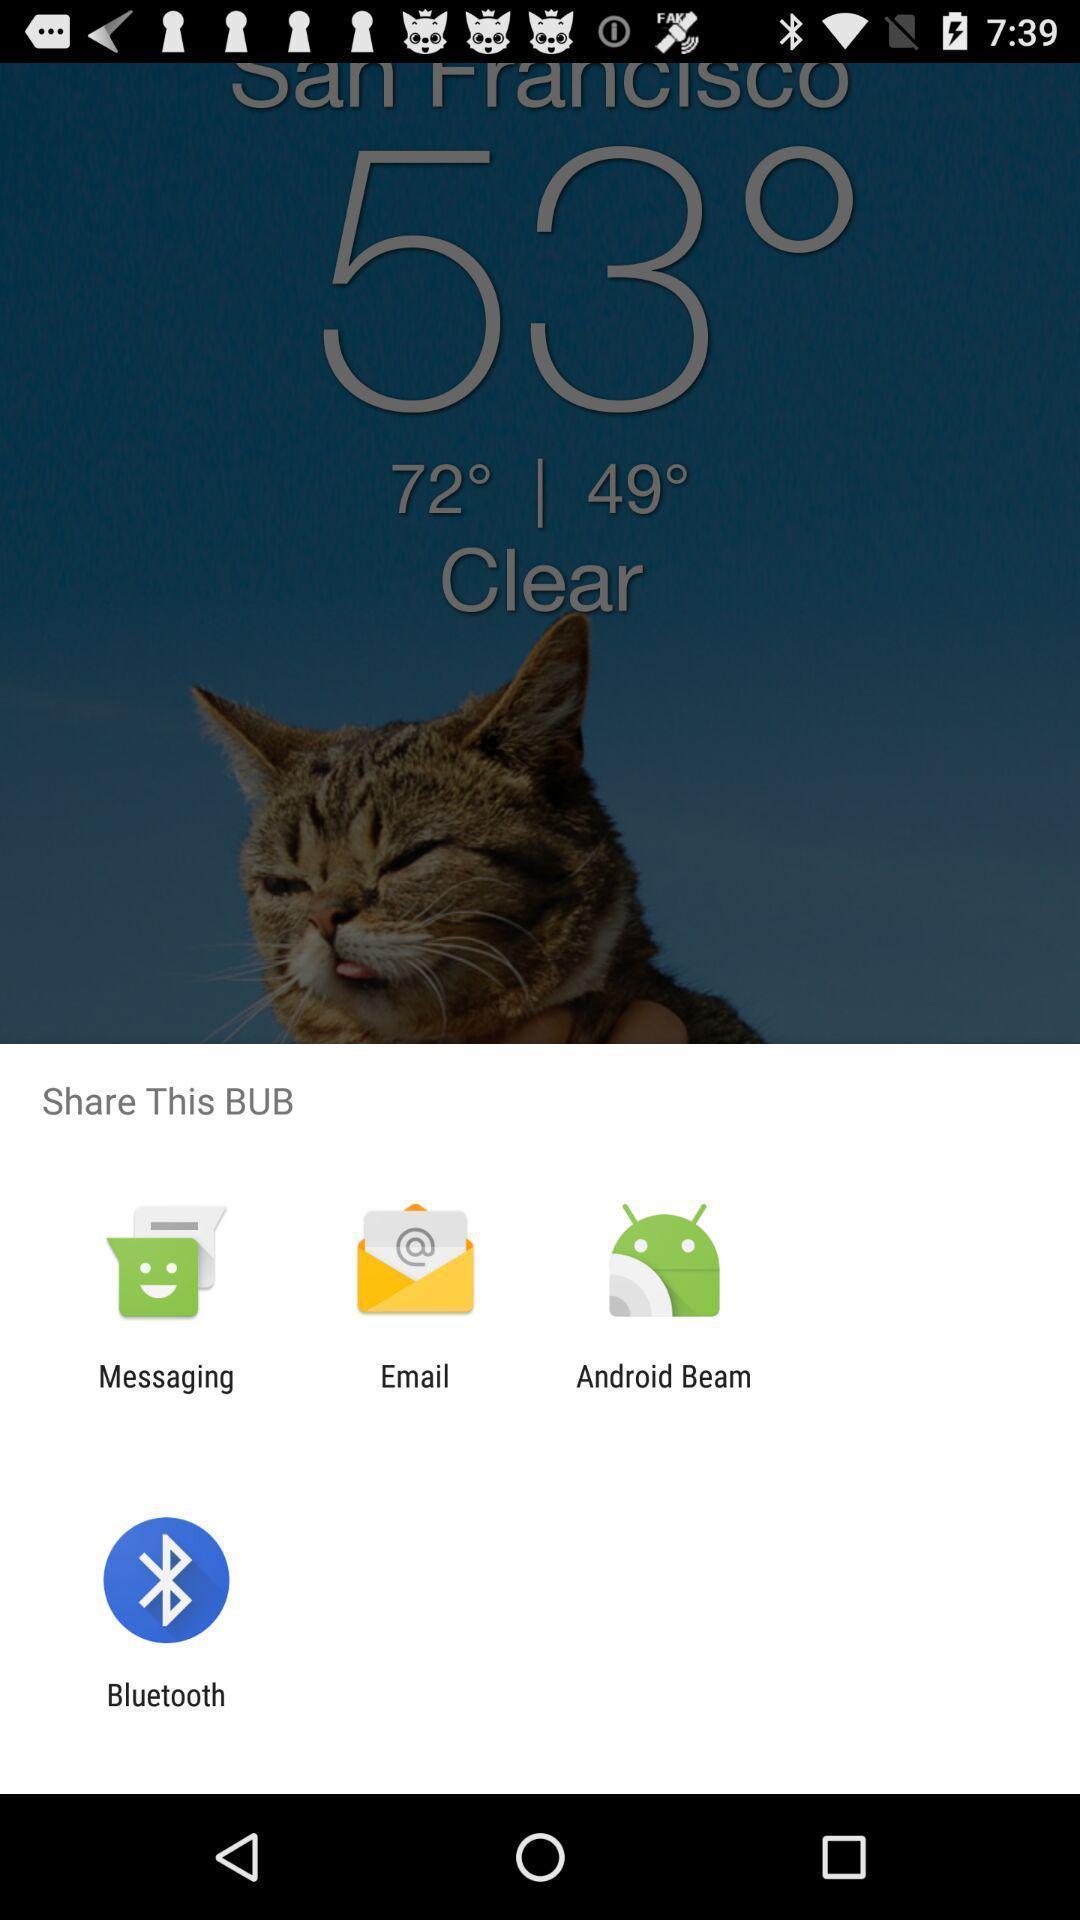Describe the key features of this screenshot. Pop-up showing various options to share. 